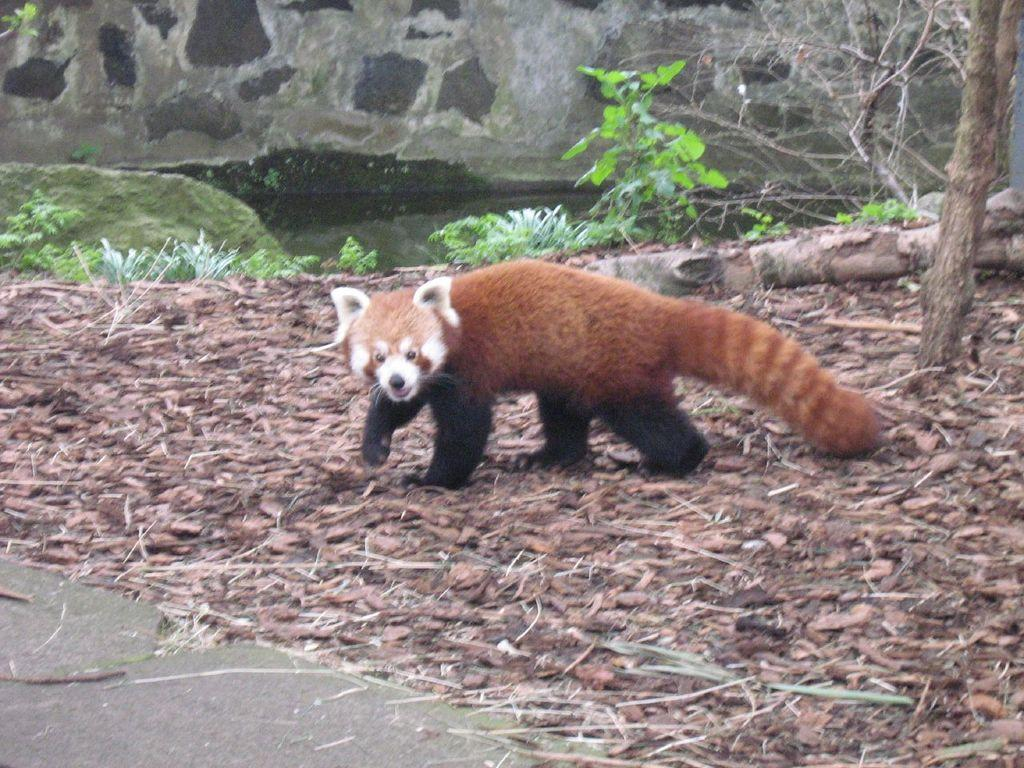What type of animal is in the image? There is a red panda in the image. Where is the red panda located? The red panda is on the ground. What can be seen on the ground around the red panda? Dry leaves are present in the image. What type of vegetation is visible in the image? Plants and trees are present in the image. What other objects can be seen on the ground? Stones are present in the image. What is visible in the background of the image? There is a wall in the background of the image. Can you describe the environment in the image? The image shows a red panda in a natural setting with plants, trees, dry leaves, stones, and water visible. What type of haircut does the red panda have in the image? There is no indication of a haircut in the image, as red pandas do not have hair that can be cut. 